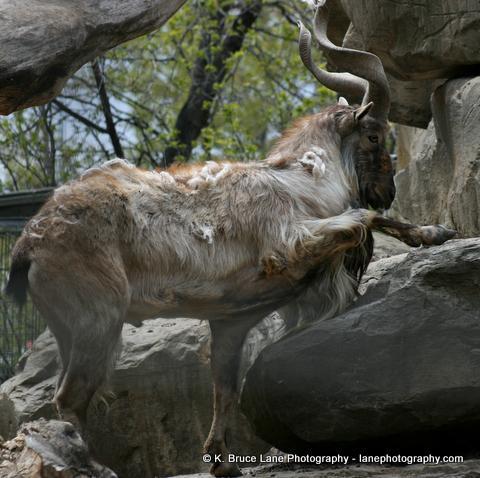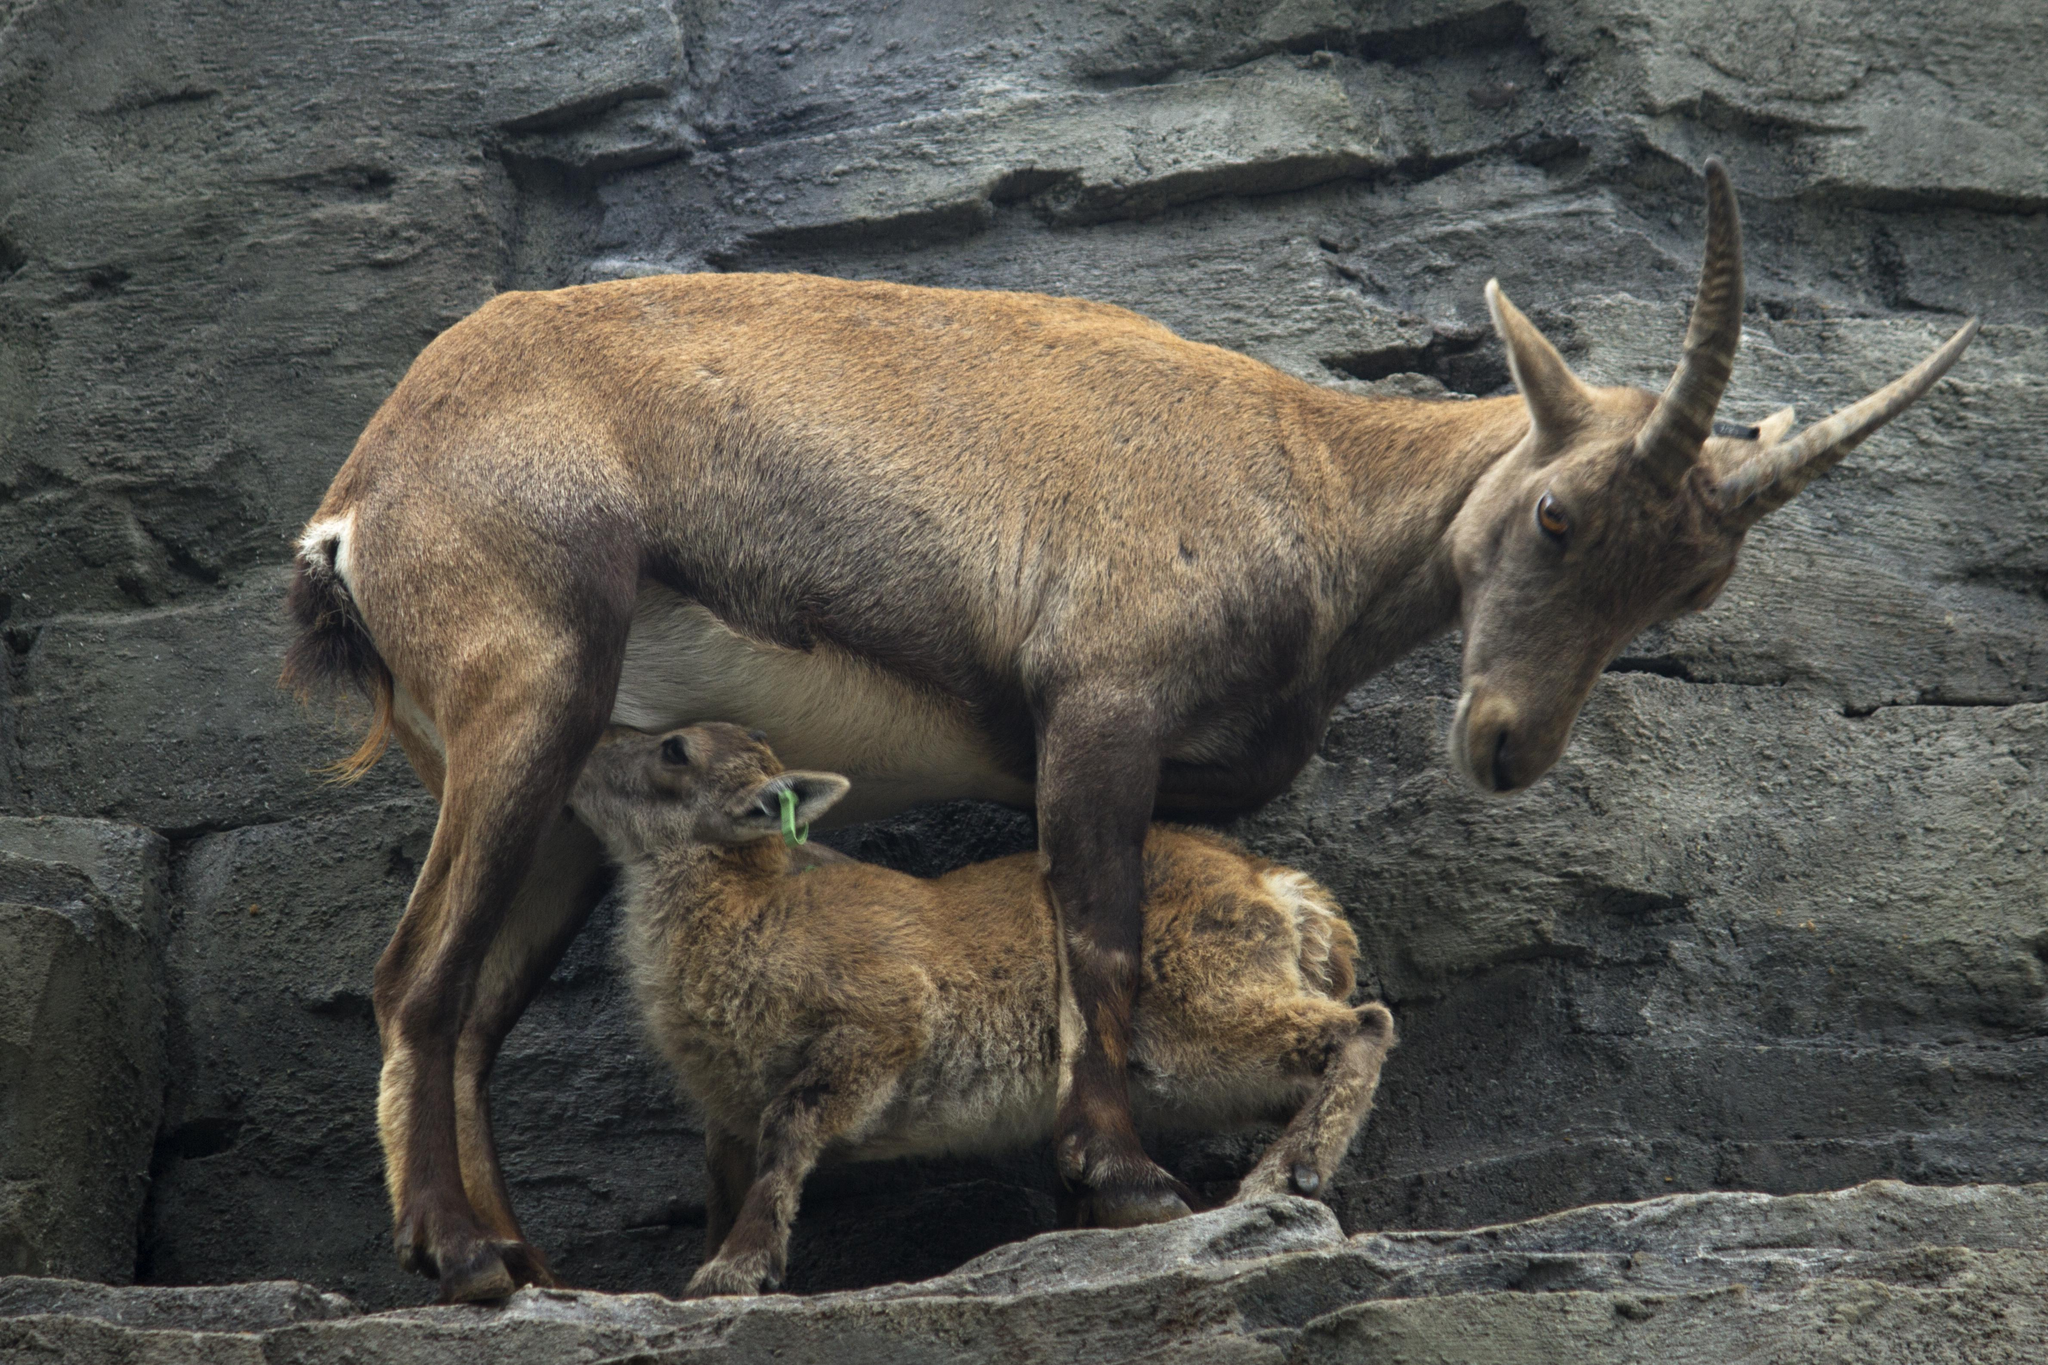The first image is the image on the left, the second image is the image on the right. Given the left and right images, does the statement "The left and right image contains the same number of goats." hold true? Answer yes or no. No. The first image is the image on the left, the second image is the image on the right. Examine the images to the left and right. Is the description "The large ram is standing near small rams in one of the images." accurate? Answer yes or no. Yes. 